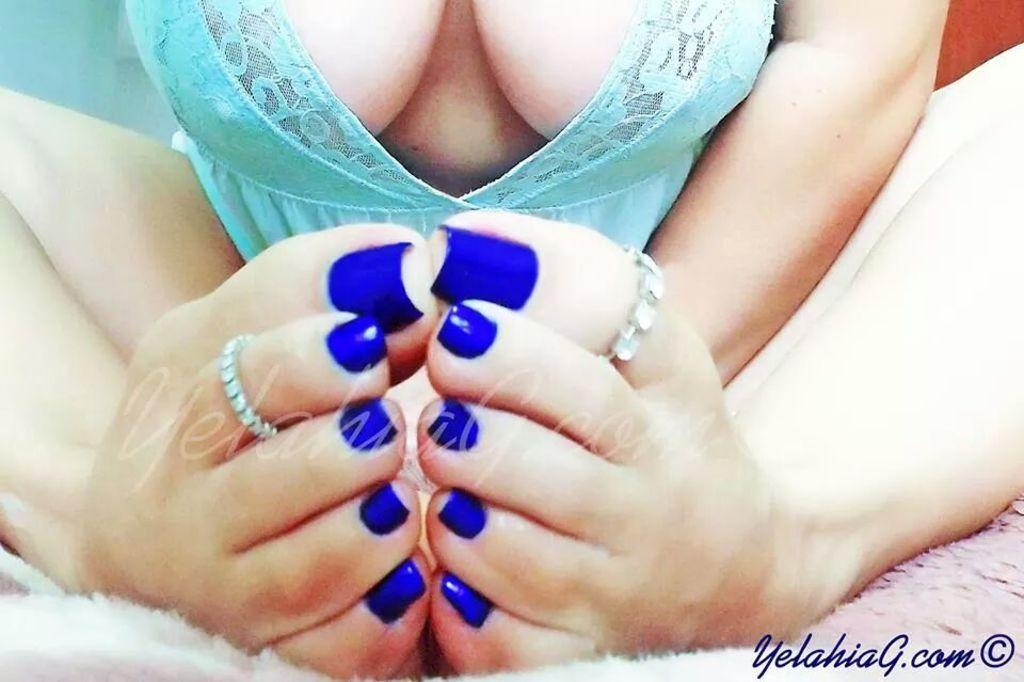Who is present in the image? There is a person in the image. What is the person wearing? The person is wearing a blue dress. What type of flooring is visible in the image? There is a carpet in the image. What color is the person's nail paint? The person has blue nail paint on their nails. What type of wood is the person using for their vacation in the image? There is no wood or vacation mentioned in the image; it only features a person wearing a blue dress and a carpet. 